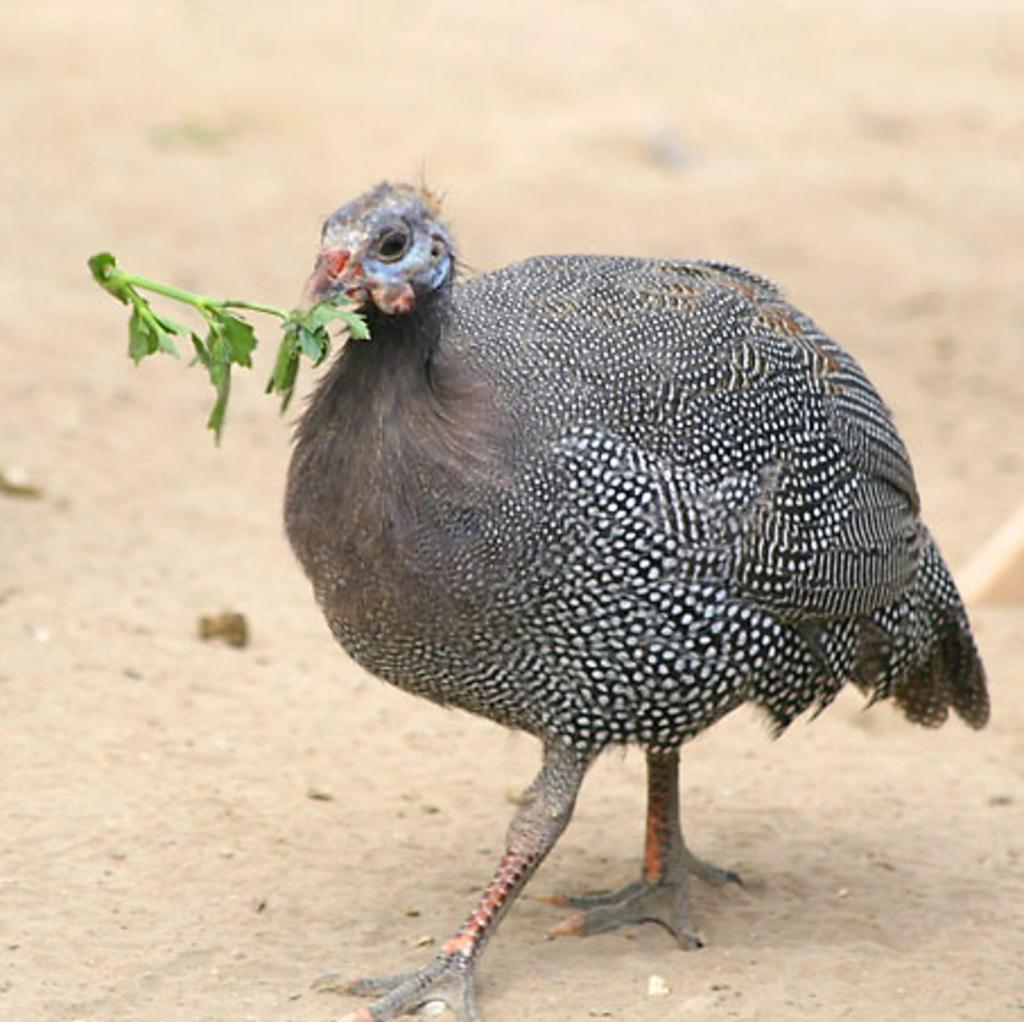What type of animal is in the image? There is a hen in the image. What is the hen doing in the image? The hen has leaves in its mouth. What type of record is the hen holding in the image? There is no record present in the image; it only features a hen with leaves in its mouth. 